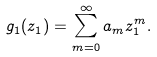<formula> <loc_0><loc_0><loc_500><loc_500>g _ { 1 } ( z _ { 1 } ) = \sum _ { m = 0 } ^ { \infty } a _ { m } z _ { 1 } ^ { m } .</formula> 